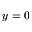<formula> <loc_0><loc_0><loc_500><loc_500>y = 0</formula> 